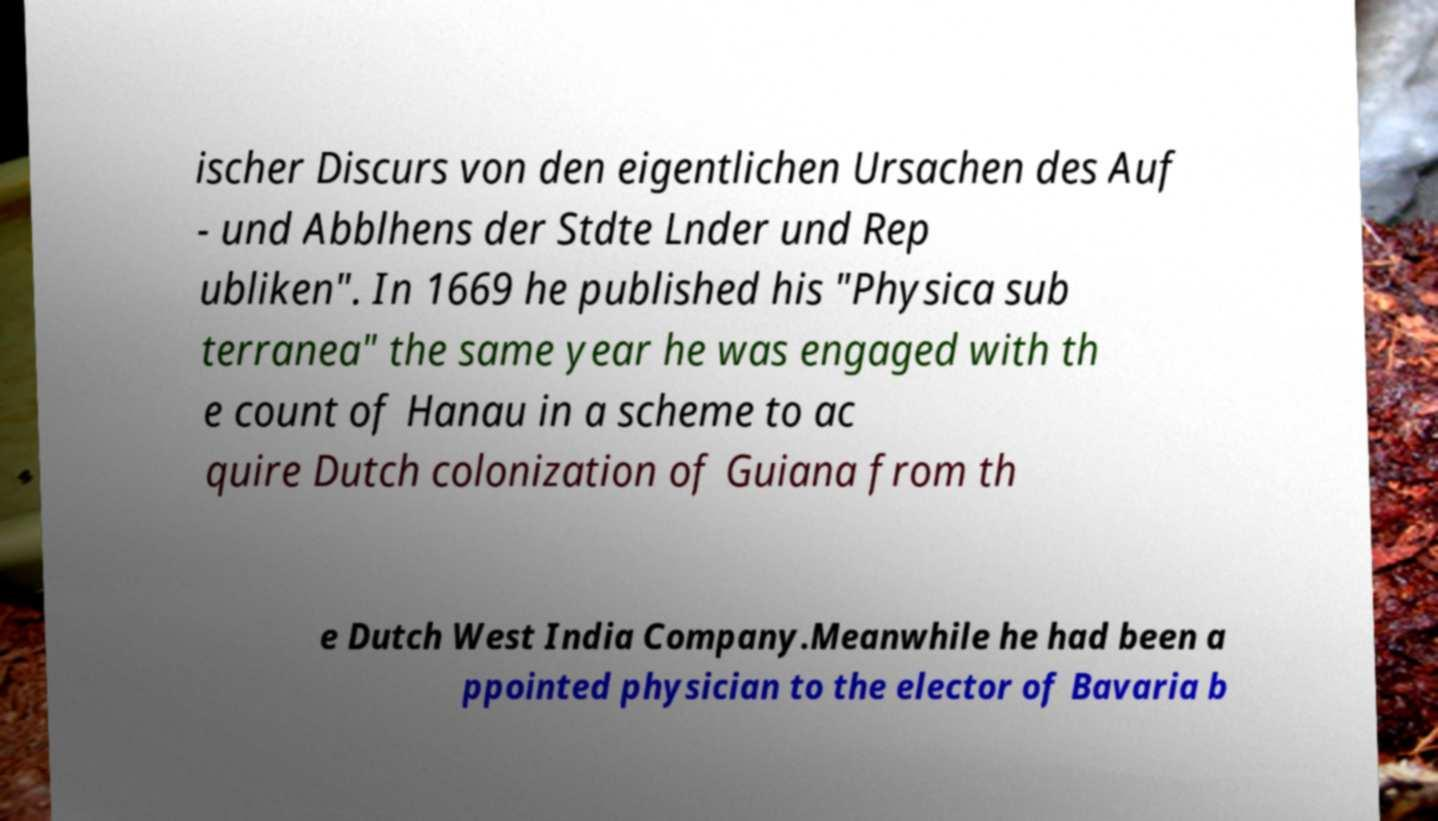Please read and relay the text visible in this image. What does it say? ischer Discurs von den eigentlichen Ursachen des Auf - und Abblhens der Stdte Lnder und Rep ubliken". In 1669 he published his "Physica sub terranea" the same year he was engaged with th e count of Hanau in a scheme to ac quire Dutch colonization of Guiana from th e Dutch West India Company.Meanwhile he had been a ppointed physician to the elector of Bavaria b 